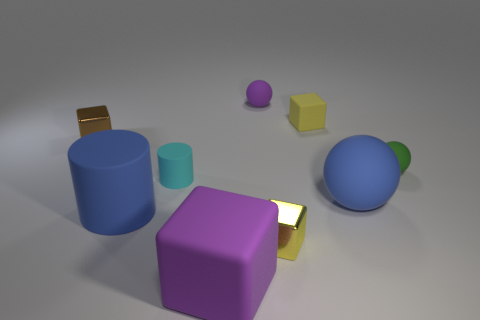How could the arrangement of these objects inform us about the principles of composition in visual design? This image is a prime example of visual balance and contrast. The distribution of different sized objects across the frame creates a sense of balance without symmetry. The varied colors used range from cool to warm, which draws the viewer's eye across the composition. Their arrangement also allows for an exploration of depth, as the placement of objects in the foreground and background can play with perspective, giving a sense of three-dimensional space on a two-dimensional medium. 